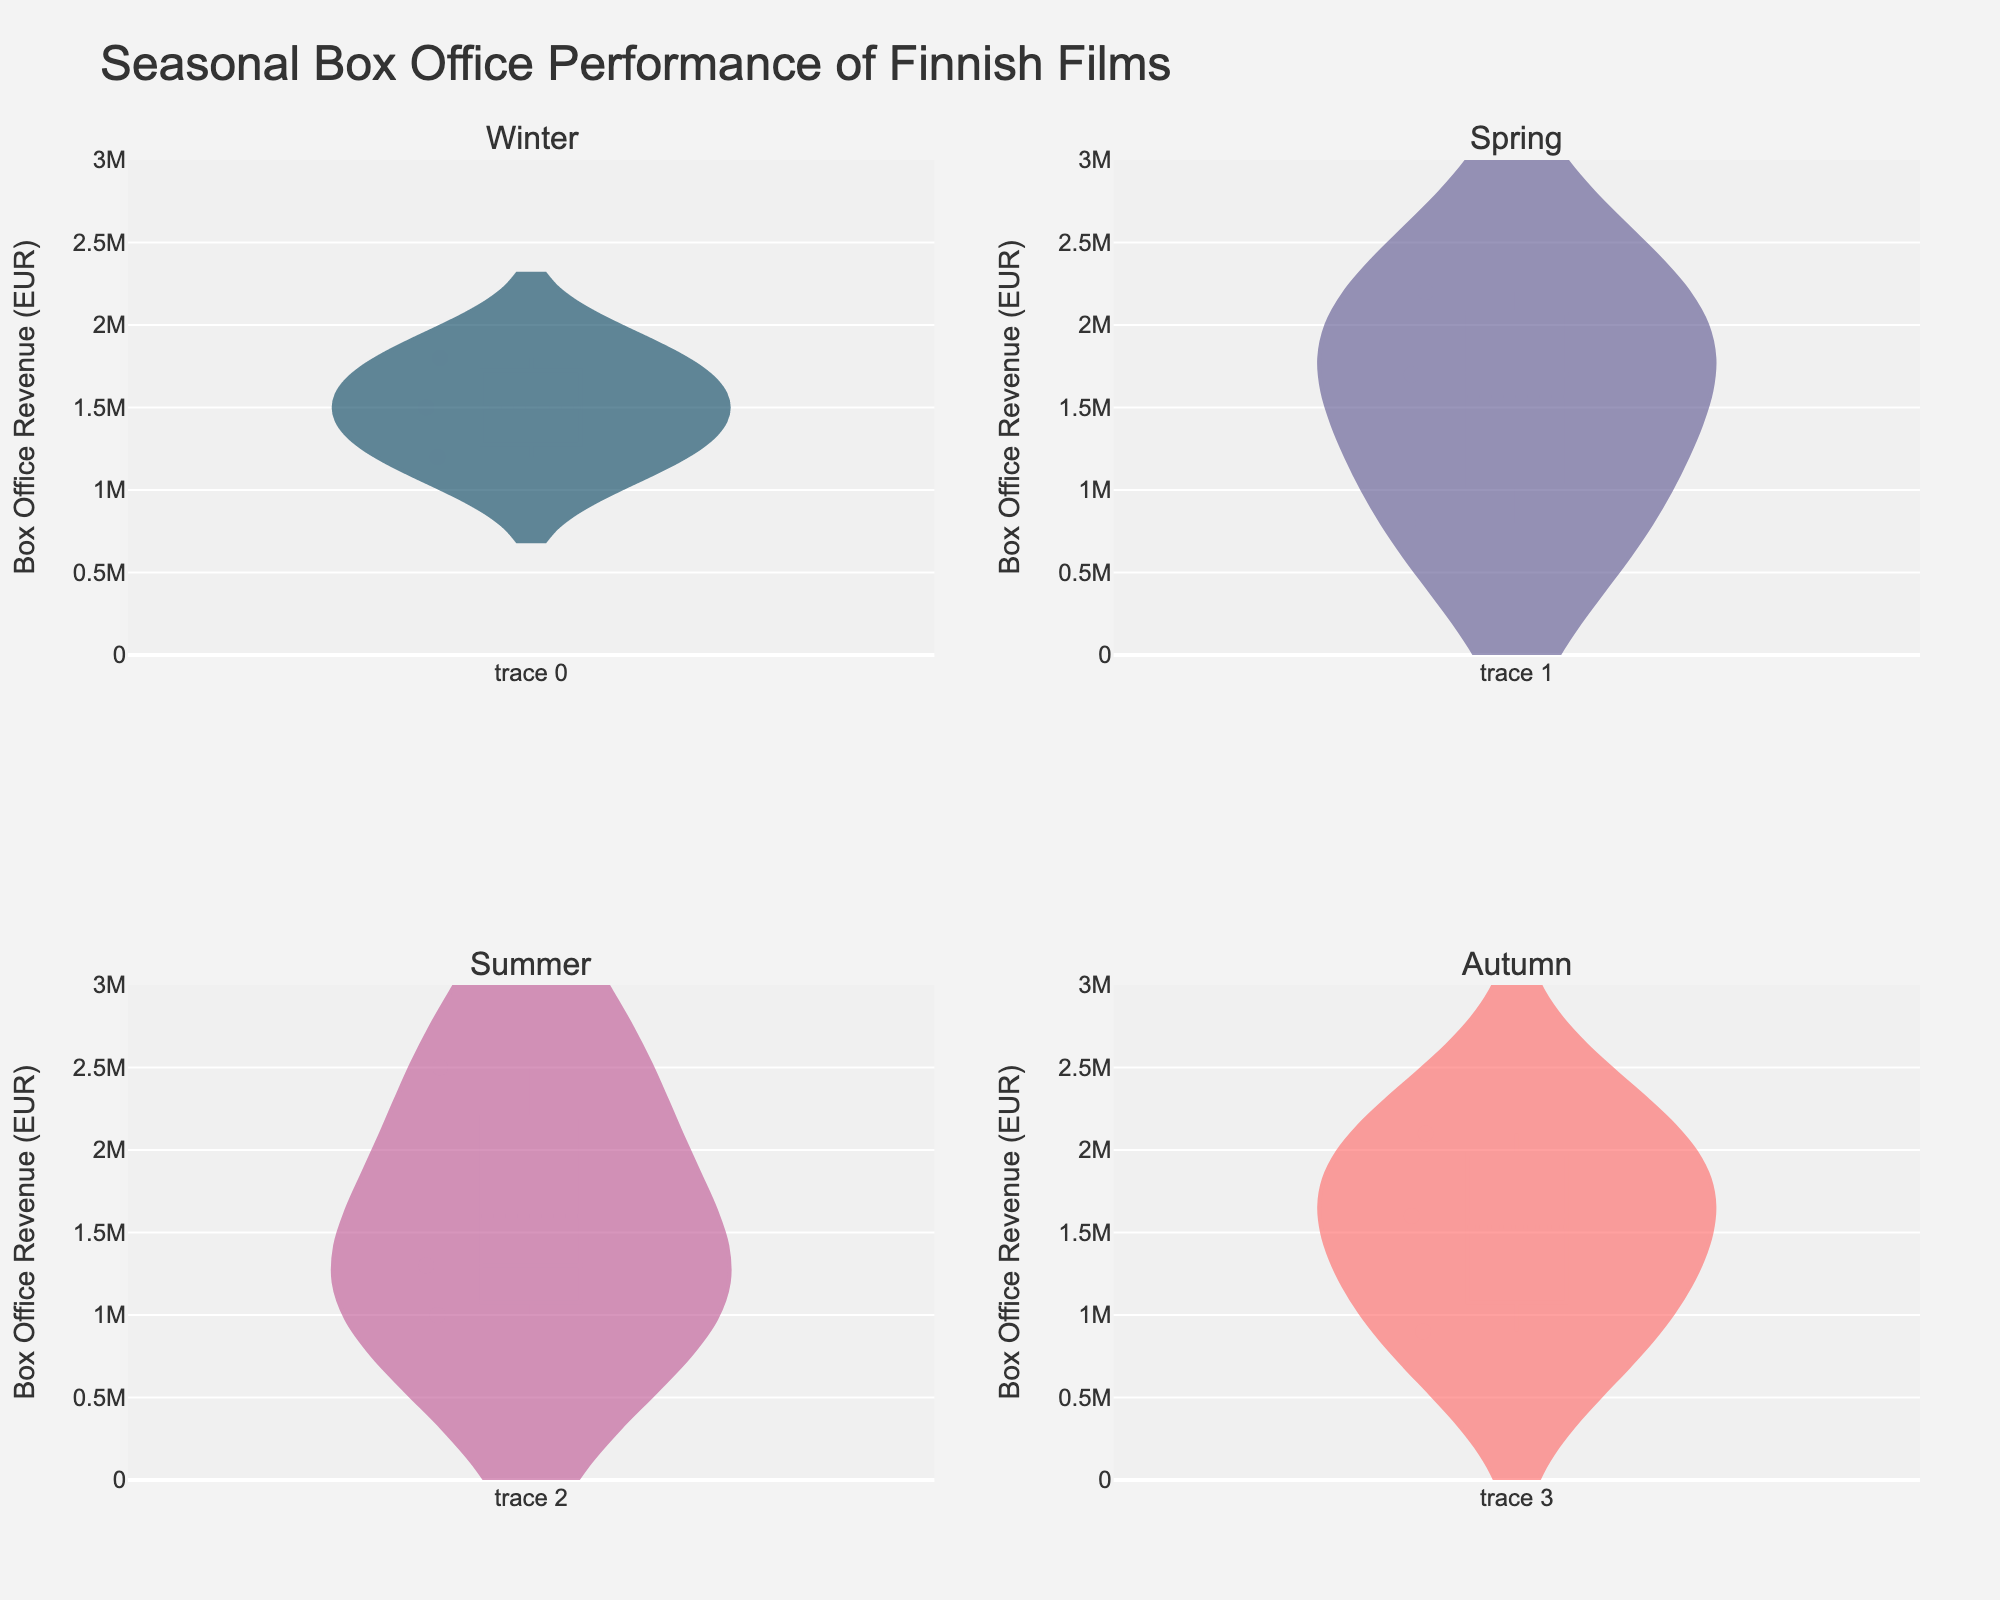Which season has the highest median box office revenue? To find this, look at the central line in each of the violin plots, which represents the median value. Compare the medians across the four seasons.
Answer: Summer How many films were released in Winter? The points in the Winter subplot represent each film. Count the number of points within the Winter subplot.
Answer: 3 Which season has the largest range of box office revenues? To determine the range, look at the length of the violin plots. The longer the plot, the larger the range of box office revenues. Compare the lengths across the seasons.
Answer: Summer What's the box office revenue of "The Unknown Soldier"? Find "The Unknown Soldier" in the Spring subplot by hovering over the points or reading the hover text, then identify the corresponding box office revenue on the y-axis.
Answer: 2,200,000 EUR Which season has the lowest average box office revenue based on the visual information? Compute the average by visually estimating the center of distribution of each plot. For instance, look for where most data points seem to cluster and compare across the plots.
Answer: Spring In which season does the film with the highest box office revenue fall? Identify the point which reaches the highest on the y-axis and see which subplot it belongs to.
Answer: Summer How does the box office performance in Autumn compare to that in Winter? Compare the general shape, median line, and spread of the two violin plots. Autumn appears to have higher median and more spread-out revenue compared to Winter.
Answer: Autumn is higher What is the approximate median box office revenue for films released in Autumn? Look at the central line of the Autumn subplot, which represents the median. Estimate its position on the y-axis.
Answer: ~1,600,000 EUR Which season has the most evenly distributed box office revenues? Look at the shape of the violin plots. A more symmetrical and uniformly spread plot indicates more even distribution.
Answer: Autumn 